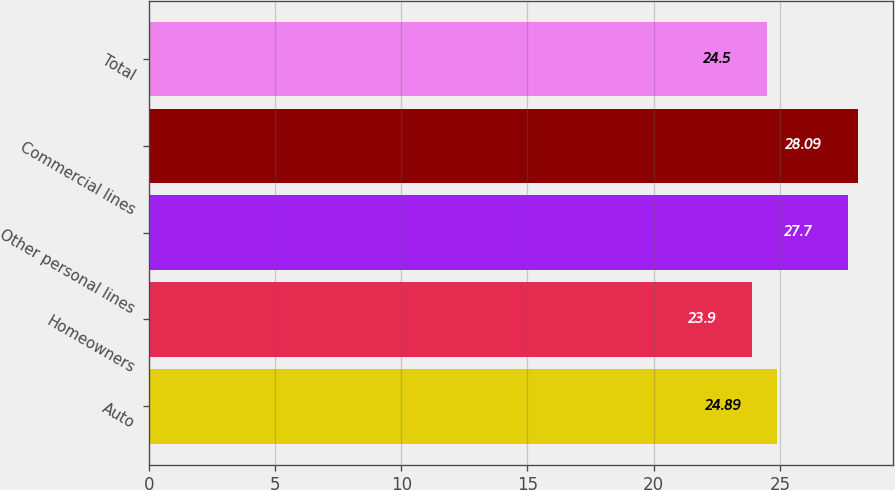<chart> <loc_0><loc_0><loc_500><loc_500><bar_chart><fcel>Auto<fcel>Homeowners<fcel>Other personal lines<fcel>Commercial lines<fcel>Total<nl><fcel>24.89<fcel>23.9<fcel>27.7<fcel>28.09<fcel>24.5<nl></chart> 